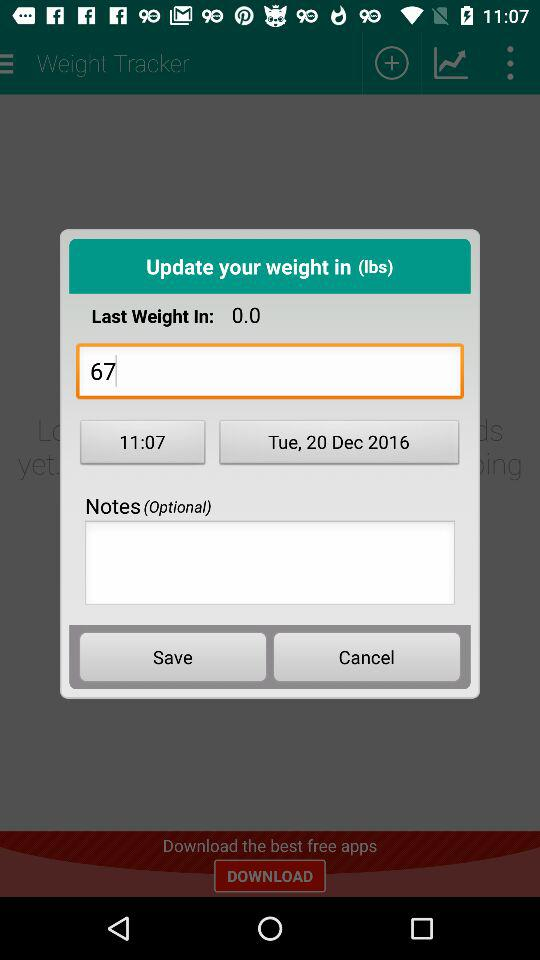What is the date? The date is Tuesday, December 20, 2016. 